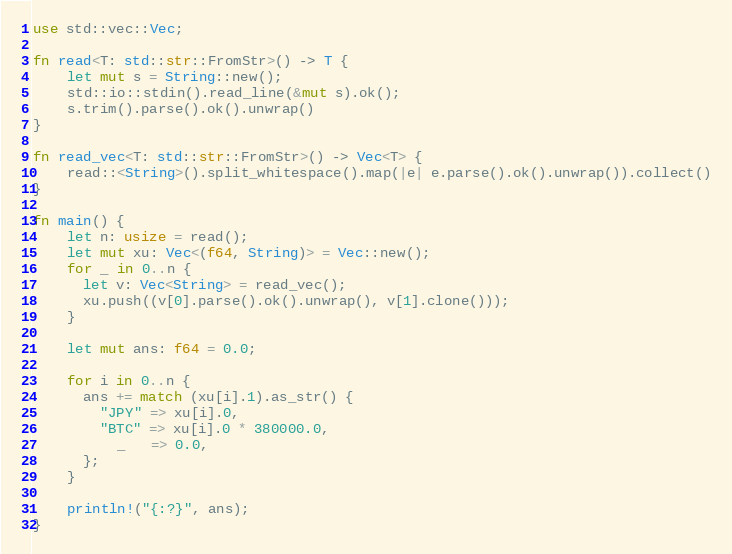Convert code to text. <code><loc_0><loc_0><loc_500><loc_500><_Rust_>use std::vec::Vec;

fn read<T: std::str::FromStr>() -> T {
    let mut s = String::new();
    std::io::stdin().read_line(&mut s).ok();
    s.trim().parse().ok().unwrap()
}

fn read_vec<T: std::str::FromStr>() -> Vec<T> {
    read::<String>().split_whitespace().map(|e| e.parse().ok().unwrap()).collect()
}

fn main() {
    let n: usize = read();
    let mut xu: Vec<(f64, String)> = Vec::new();
    for _ in 0..n {
      let v: Vec<String> = read_vec();
      xu.push((v[0].parse().ok().unwrap(), v[1].clone()));
    }

    let mut ans: f64 = 0.0;

    for i in 0..n {
      ans += match (xu[i].1).as_str() {
        "JPY" => xu[i].0,
        "BTC" => xu[i].0 * 380000.0,
          _   => 0.0,
      };
    }

    println!("{:?}", ans);
}
</code> 